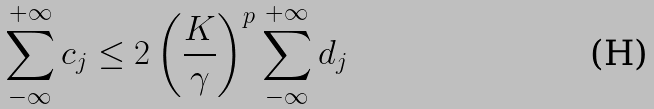<formula> <loc_0><loc_0><loc_500><loc_500>\sum _ { - \infty } ^ { + \infty } c _ { j } \leq 2 \left ( \frac { K } { \gamma } \right ) ^ { p } \sum _ { - \infty } ^ { + \infty } d _ { j }</formula> 